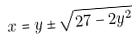Convert formula to latex. <formula><loc_0><loc_0><loc_500><loc_500>x = y \pm \sqrt { 2 7 - 2 y ^ { 2 } }</formula> 